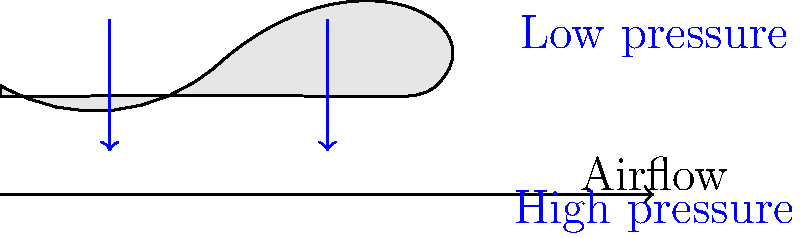Greetings, fellow space traveler! As a curious Martian studying Earth's flying machines, you've encountered a peculiar phenomenon. The humans use a curved surface called an "airfoil" to generate lift for their airplanes. Based on the diagram, which shows the airflow and pressure distribution around an airplane wing, what principle explains why the air moves faster over the top of the wing compared to the bottom? Let's decode this Earth technology step by step:

1. Observe the wing shape: The top surface is more curved than the bottom surface.

2. Air particles dilemma: Air separating at the leading edge must reunite at the trailing edge.

3. Distance discrepancy: Due to the curvature, the path over the top is longer than the bottom.

4. Bernoulli's principle: This Earth physics concept states that as the speed of a fluid increases, its pressure decreases.

5. Speed difference: To cover the longer distance in the same time, air must move faster over the top surface.

6. Pressure difference: According to Bernoulli's principle, faster-moving air on top creates lower pressure compared to the bottom.

7. Lift generation: The pressure difference between the top and bottom surfaces creates an upward force called lift.

The key principle at work here is the conservation of mass in fluid dynamics, combined with Bernoulli's principle. The wing's shape forces air to move faster over the top, creating a pressure difference that generates lift.
Answer: Conservation of mass and Bernoulli's principle 